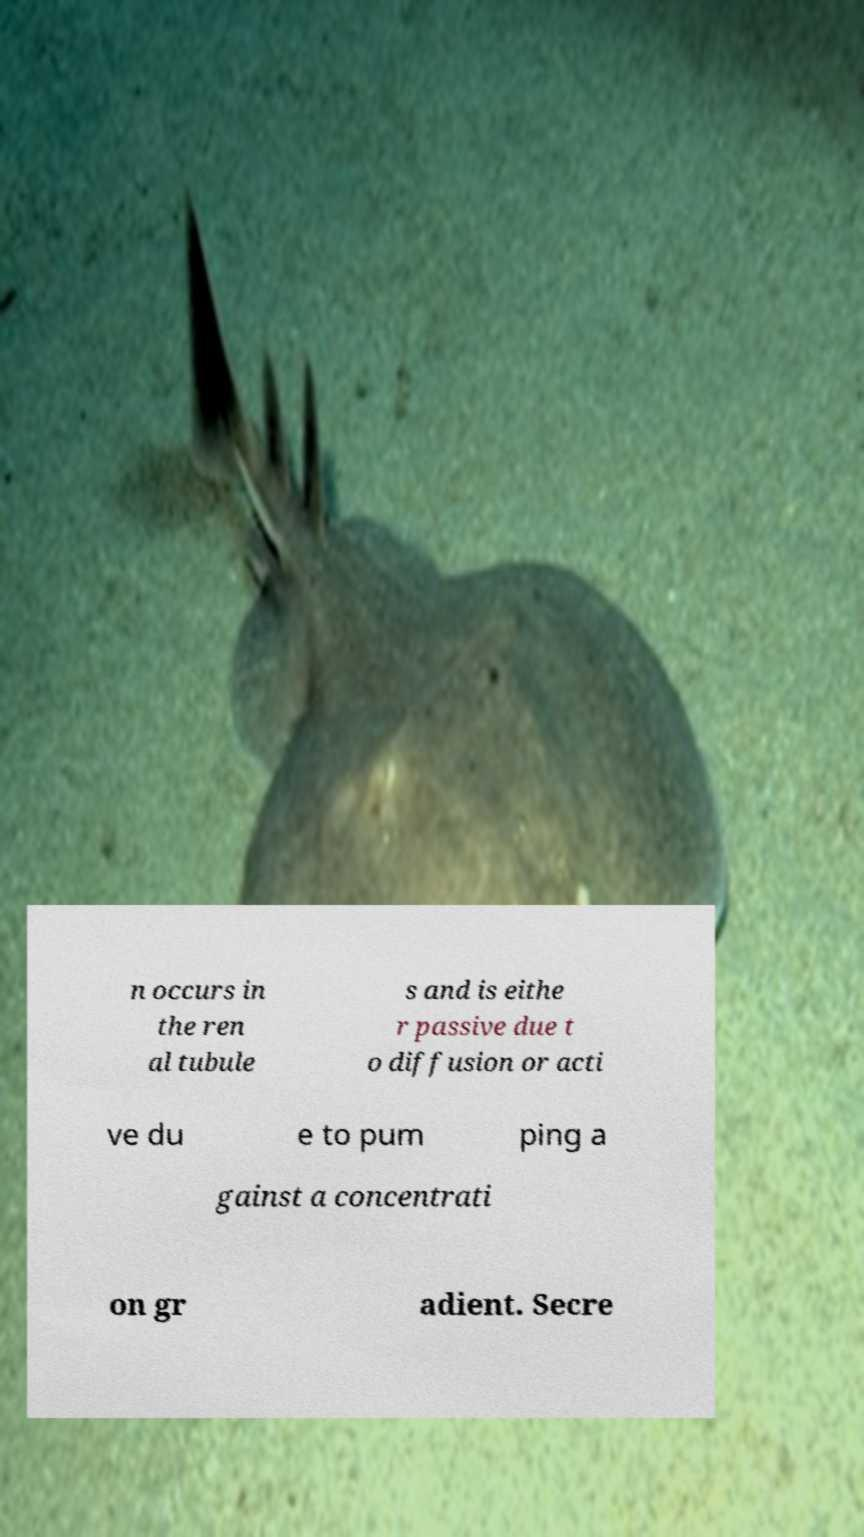What messages or text are displayed in this image? I need them in a readable, typed format. n occurs in the ren al tubule s and is eithe r passive due t o diffusion or acti ve du e to pum ping a gainst a concentrati on gr adient. Secre 